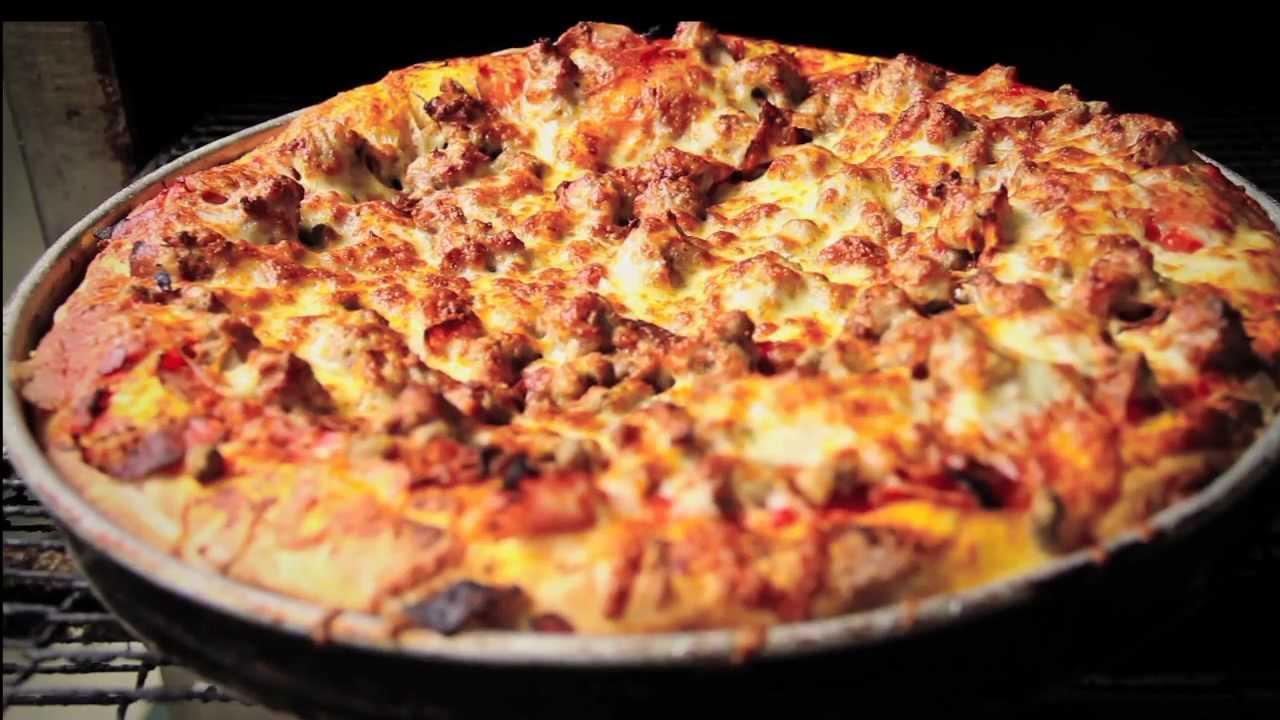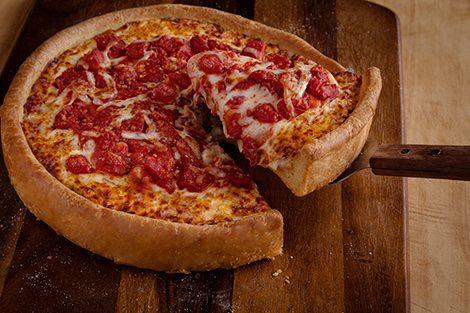The first image is the image on the left, the second image is the image on the right. Examine the images to the left and right. Is the description "One image shows a round pizza in a round pan with no slices removed, and the other image shows a pizza slice that is not joined to the rest of the pizza." accurate? Answer yes or no. Yes. 